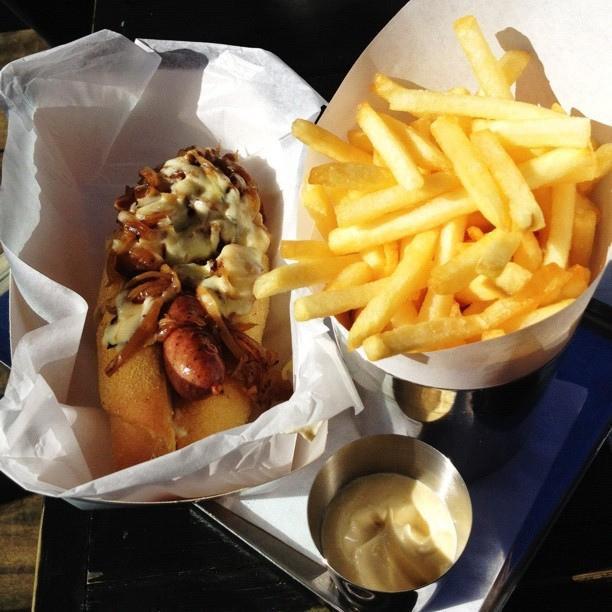What place sells these items?
Choose the correct response, then elucidate: 'Answer: answer
Rationale: rationale.'
Options: Taco bell, home depot, sonic, staples. Answer: sonic.
Rationale: Sonic is known to sell hot dogs. the other options do not sell hot dogs. 